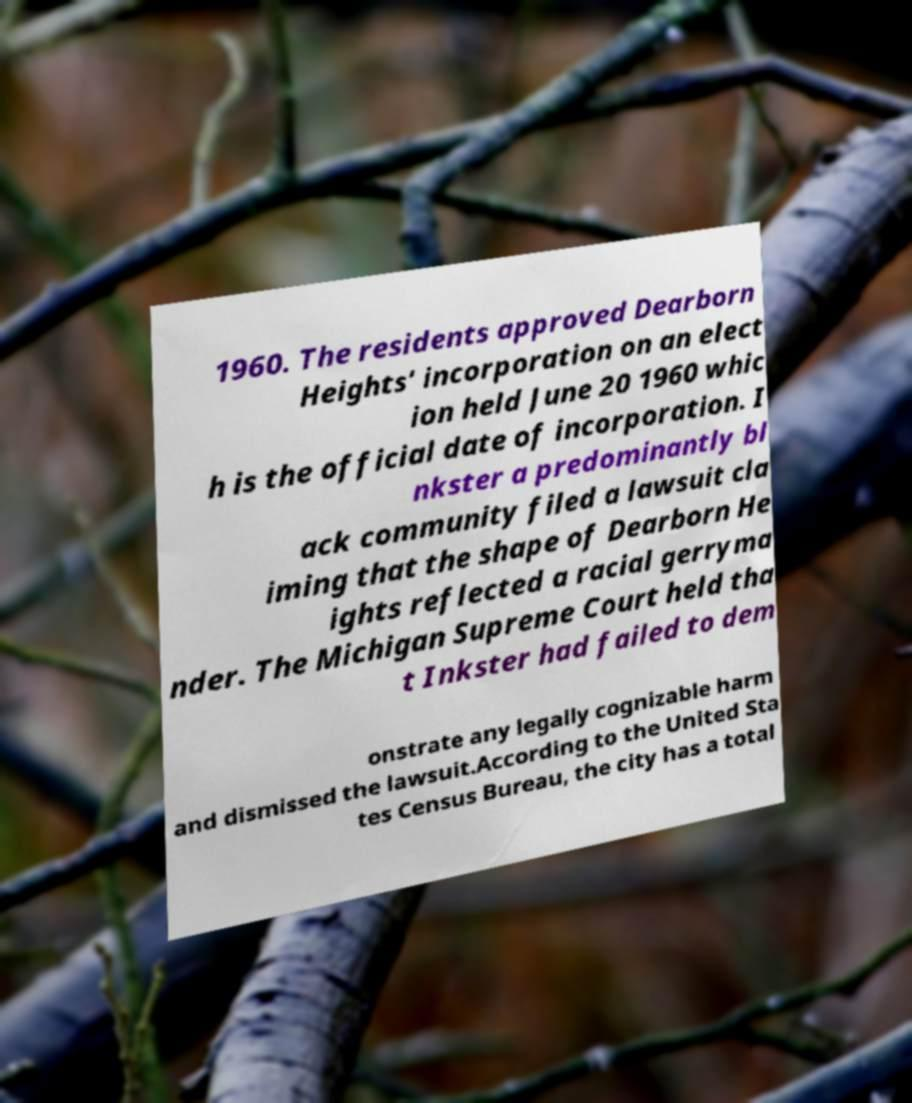For documentation purposes, I need the text within this image transcribed. Could you provide that? 1960. The residents approved Dearborn Heights' incorporation on an elect ion held June 20 1960 whic h is the official date of incorporation. I nkster a predominantly bl ack community filed a lawsuit cla iming that the shape of Dearborn He ights reflected a racial gerryma nder. The Michigan Supreme Court held tha t Inkster had failed to dem onstrate any legally cognizable harm and dismissed the lawsuit.According to the United Sta tes Census Bureau, the city has a total 